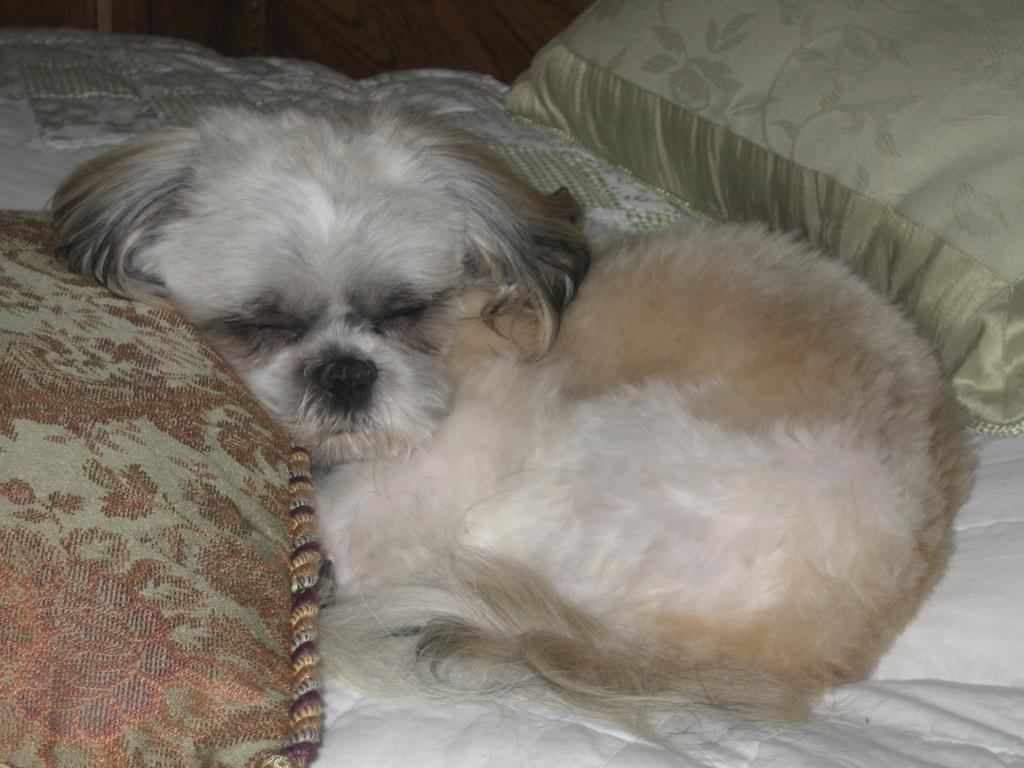What type of animal is present in the image? There is a dog in the image. What objects can be seen in the image besides the dog? There are pillows in the image. How many cherries are on the dog's elbow in the image? There are no cherries or elbows present in the image, as it features a dog and pillows. 